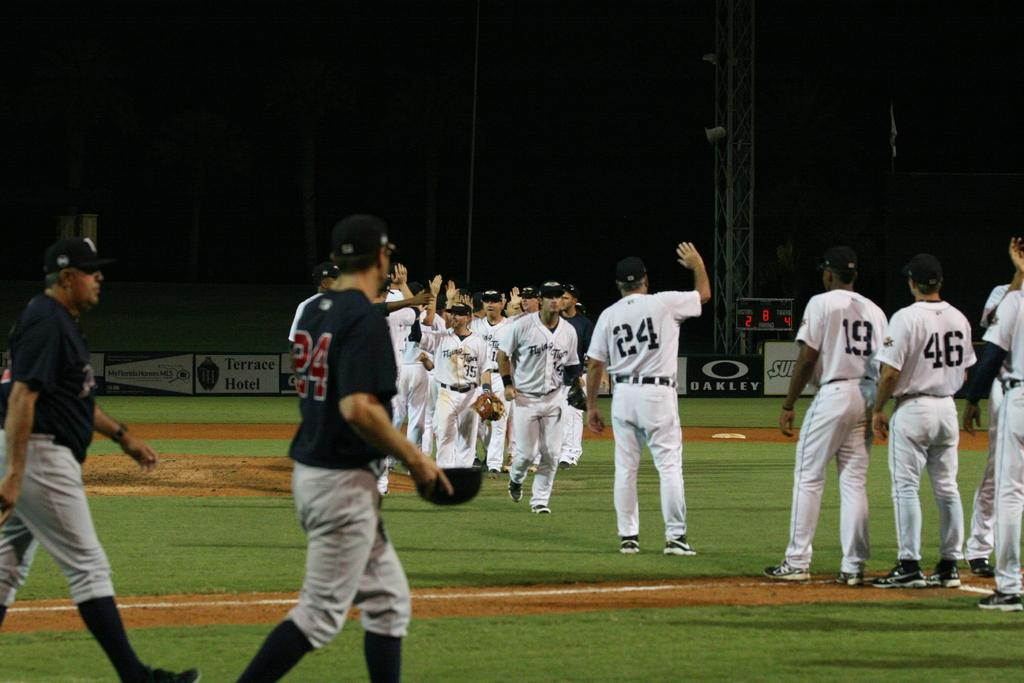<image>
Relay a brief, clear account of the picture shown. Two baseball teams are on a field with a man in a white uniform and the number 24 on his jersey getting ready to high five someone. 